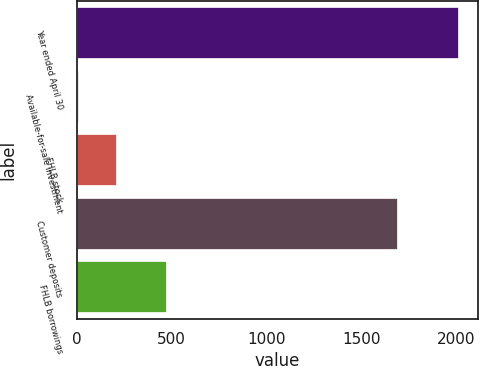Convert chart to OTSL. <chart><loc_0><loc_0><loc_500><loc_500><bar_chart><fcel>Year ended April 30<fcel>Available-for-sale investment<fcel>FHLB stock<fcel>Customer deposits<fcel>FHLB borrowings<nl><fcel>2011<fcel>7<fcel>207.4<fcel>1686<fcel>471<nl></chart> 